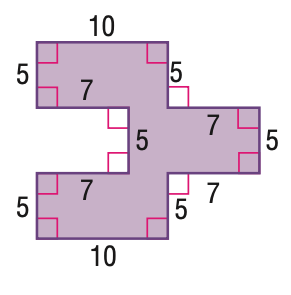Question: Find the area of the figure.
Choices:
A. 105
B. 135
C. 150
D. 160
Answer with the letter. Answer: C 